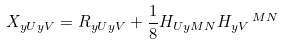<formula> <loc_0><loc_0><loc_500><loc_500>X _ { y U y V } = R _ { y U y V } + \frac { 1 } { 8 } H _ { U y M N } H _ { y V } \, ^ { M N }</formula> 